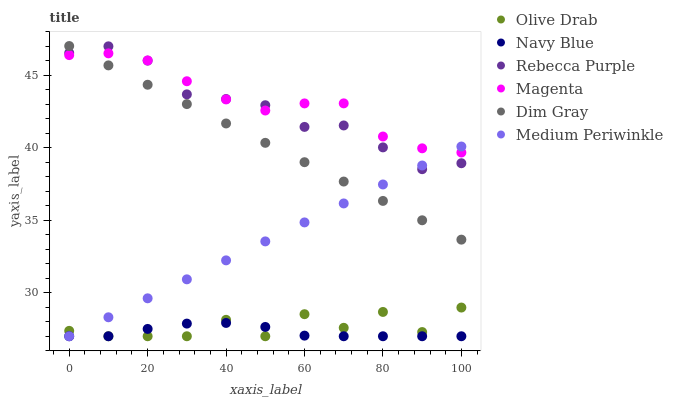Does Navy Blue have the minimum area under the curve?
Answer yes or no. Yes. Does Magenta have the maximum area under the curve?
Answer yes or no. Yes. Does Medium Periwinkle have the minimum area under the curve?
Answer yes or no. No. Does Medium Periwinkle have the maximum area under the curve?
Answer yes or no. No. Is Dim Gray the smoothest?
Answer yes or no. Yes. Is Olive Drab the roughest?
Answer yes or no. Yes. Is Navy Blue the smoothest?
Answer yes or no. No. Is Navy Blue the roughest?
Answer yes or no. No. Does Navy Blue have the lowest value?
Answer yes or no. Yes. Does Rebecca Purple have the lowest value?
Answer yes or no. No. Does Dim Gray have the highest value?
Answer yes or no. Yes. Does Medium Periwinkle have the highest value?
Answer yes or no. No. Is Olive Drab less than Rebecca Purple?
Answer yes or no. Yes. Is Magenta greater than Navy Blue?
Answer yes or no. Yes. Does Magenta intersect Medium Periwinkle?
Answer yes or no. Yes. Is Magenta less than Medium Periwinkle?
Answer yes or no. No. Is Magenta greater than Medium Periwinkle?
Answer yes or no. No. Does Olive Drab intersect Rebecca Purple?
Answer yes or no. No. 